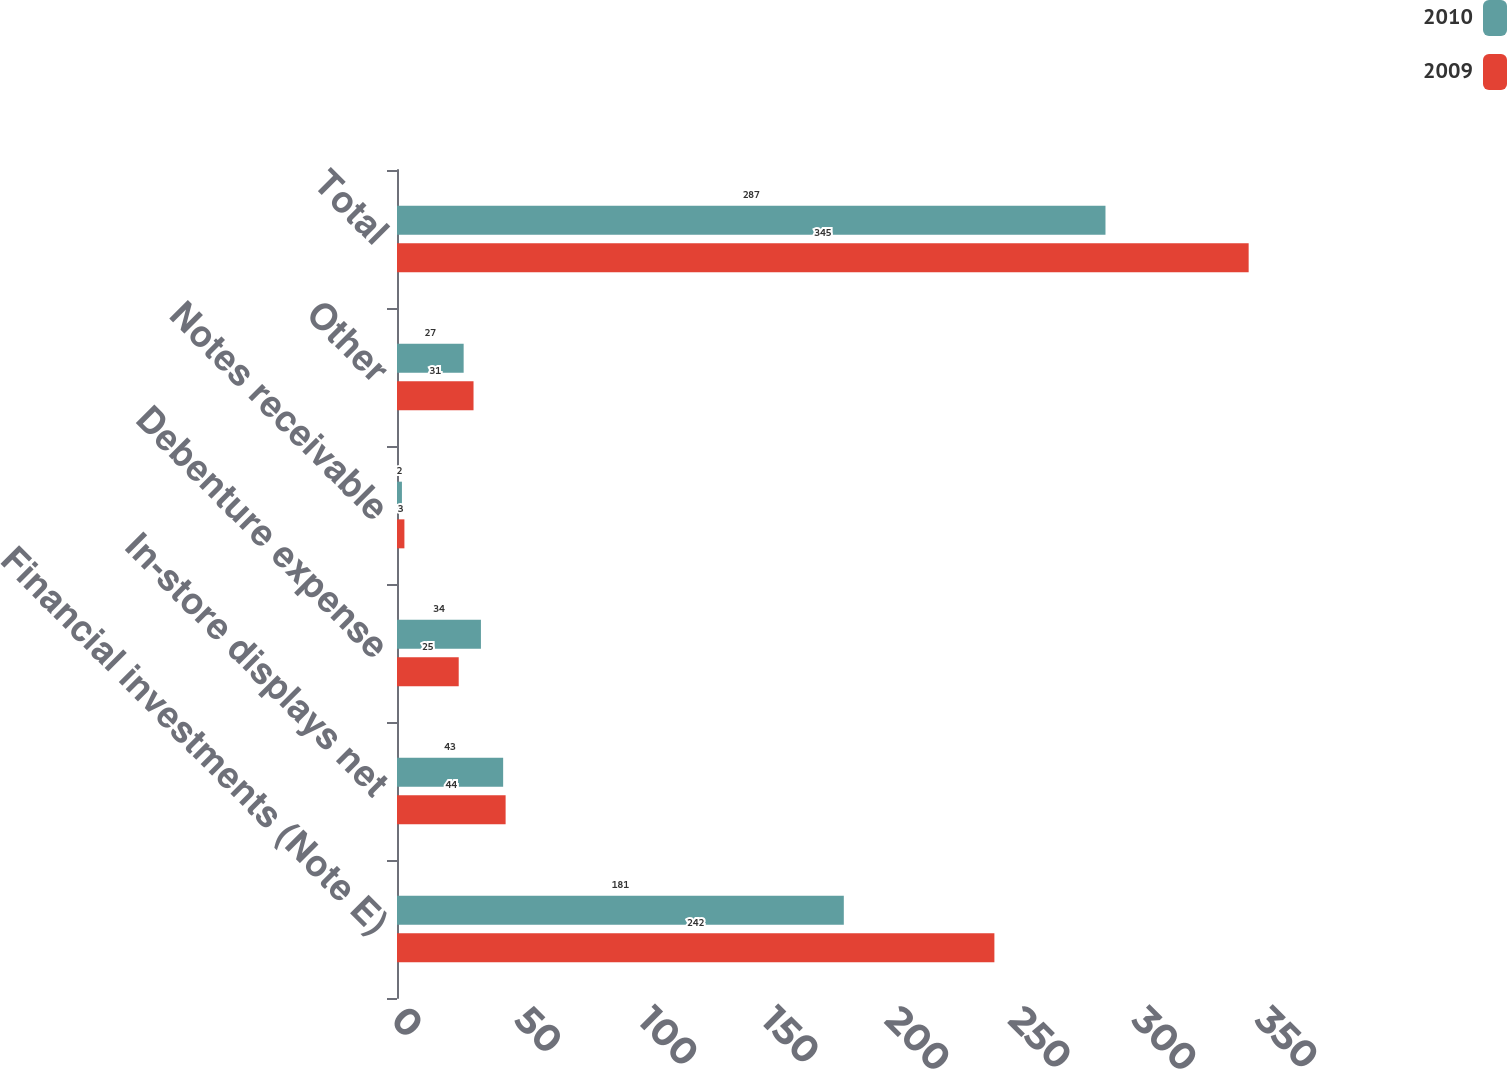Convert chart. <chart><loc_0><loc_0><loc_500><loc_500><stacked_bar_chart><ecel><fcel>Financial investments (Note E)<fcel>In-store displays net<fcel>Debenture expense<fcel>Notes receivable<fcel>Other<fcel>Total<nl><fcel>2010<fcel>181<fcel>43<fcel>34<fcel>2<fcel>27<fcel>287<nl><fcel>2009<fcel>242<fcel>44<fcel>25<fcel>3<fcel>31<fcel>345<nl></chart> 